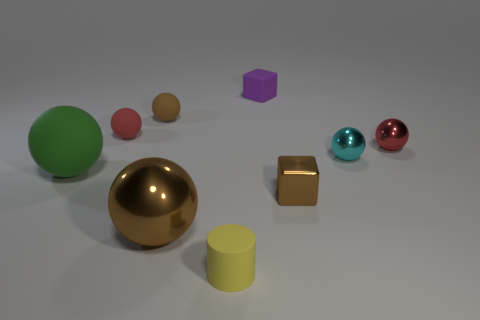Are there any other things that are the same size as the red metal object?
Ensure brevity in your answer.  Yes. What number of matte objects are the same color as the small metal cube?
Ensure brevity in your answer.  1. Is the color of the large shiny thing the same as the block in front of the large green thing?
Ensure brevity in your answer.  Yes. How many objects are either large rubber objects or small rubber things that are in front of the small red metal sphere?
Offer a terse response. 2. How big is the matte ball that is to the left of the red ball that is on the left side of the cyan ball?
Provide a succinct answer. Large. Is the number of cubes that are in front of the tiny purple matte cube the same as the number of matte cylinders behind the brown matte object?
Make the answer very short. No. There is a large ball to the left of the large metallic ball; is there a brown sphere to the right of it?
Provide a succinct answer. Yes. The small cyan thing that is made of the same material as the small brown block is what shape?
Provide a short and direct response. Sphere. Are there any other things that have the same color as the tiny metal block?
Your answer should be compact. Yes. There is a small brown ball left of the tiny block left of the brown block; what is its material?
Make the answer very short. Rubber. 